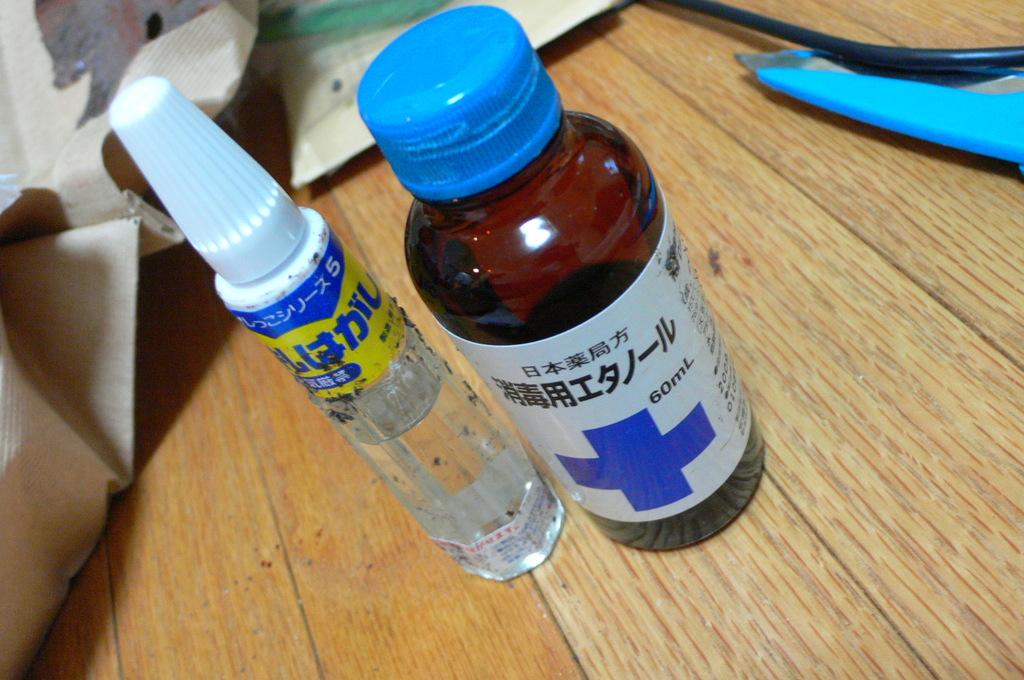What ml is the medicine?
Your answer should be very brief. 60. 